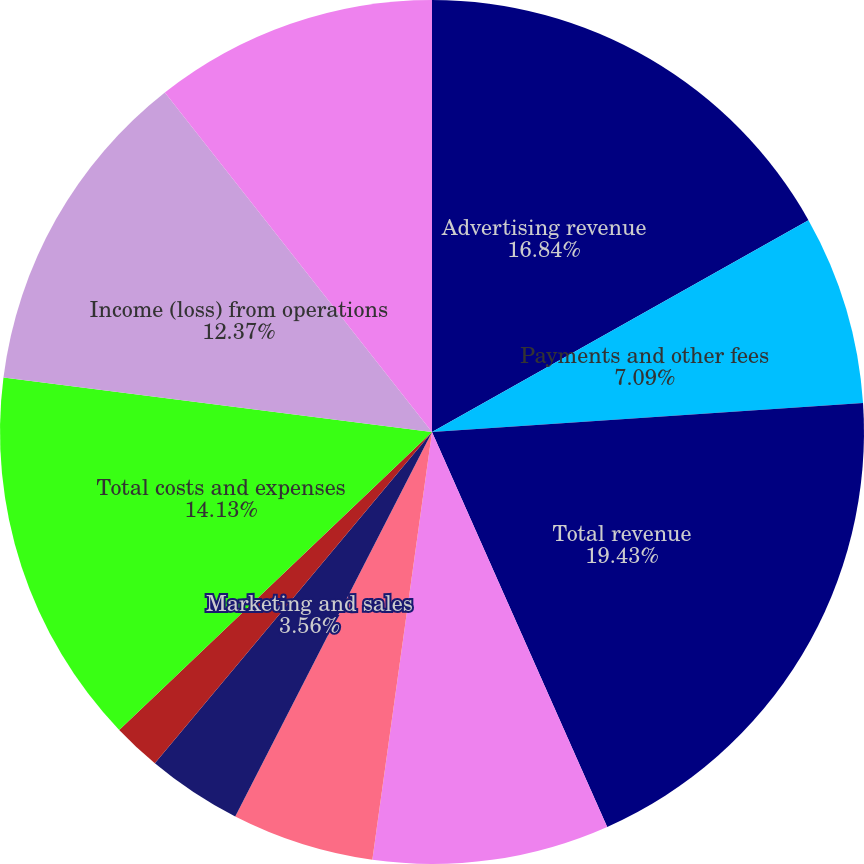<chart> <loc_0><loc_0><loc_500><loc_500><pie_chart><fcel>Advertising revenue<fcel>Payments and other fees<fcel>Total revenue<fcel>Cost of revenue<fcel>Research and development<fcel>Marketing and sales<fcel>General and administrative<fcel>Total costs and expenses<fcel>Income (loss) from operations<fcel>Income (loss) before<nl><fcel>16.84%<fcel>7.09%<fcel>19.42%<fcel>8.85%<fcel>5.32%<fcel>3.56%<fcel>1.8%<fcel>14.13%<fcel>12.37%<fcel>10.61%<nl></chart> 